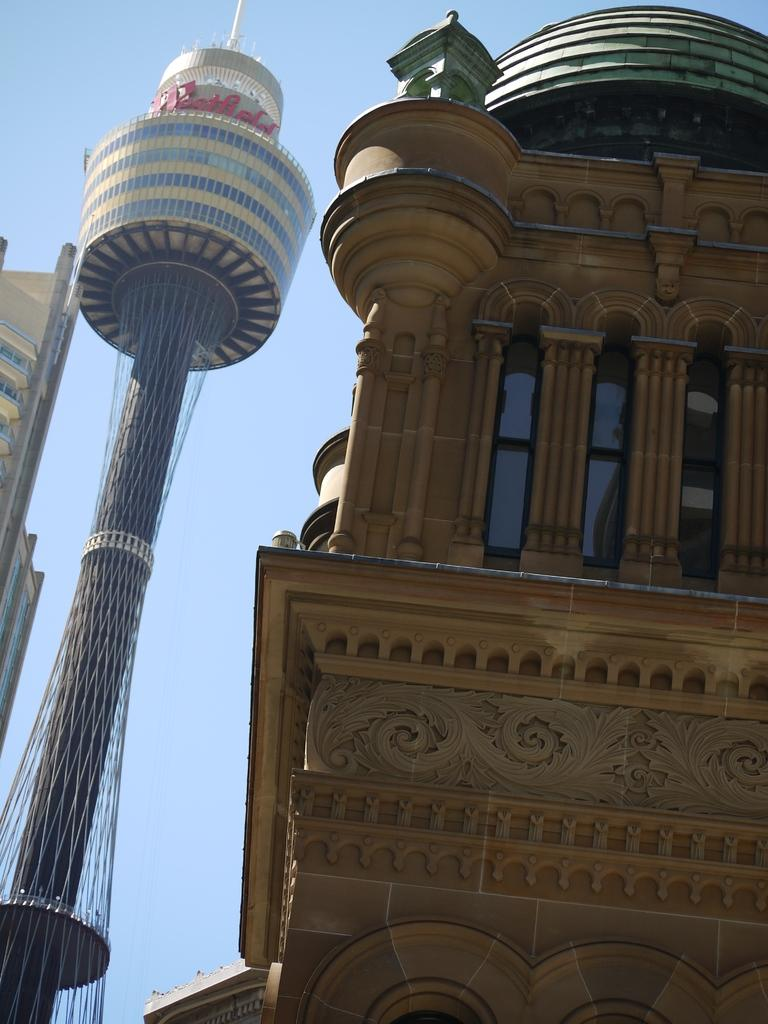What type of structure is featured in the image? There is a building with nicely carved designs in the image. What other architectural feature is present near the building? There is a big tower beside the building. What can be seen in the background of the image? The sky is visible in the background. How many clocks are hanging on the walls of the building in the image? There is no information about clocks in the image, so we cannot determine how many are present. 